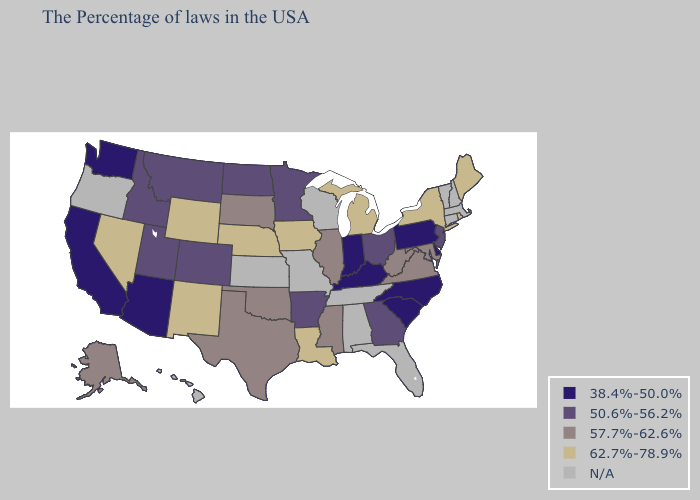Does the first symbol in the legend represent the smallest category?
Write a very short answer. Yes. Does New Jersey have the lowest value in the Northeast?
Answer briefly. No. What is the lowest value in the South?
Be succinct. 38.4%-50.0%. Among the states that border California , which have the lowest value?
Concise answer only. Arizona. Does Rhode Island have the highest value in the USA?
Short answer required. Yes. Which states have the lowest value in the South?
Keep it brief. Delaware, North Carolina, South Carolina, Kentucky. Name the states that have a value in the range 62.7%-78.9%?
Be succinct. Maine, Rhode Island, New York, Michigan, Louisiana, Iowa, Nebraska, Wyoming, New Mexico, Nevada. What is the value of Colorado?
Answer briefly. 50.6%-56.2%. Among the states that border Connecticut , which have the highest value?
Answer briefly. Rhode Island, New York. Does Maryland have the lowest value in the South?
Concise answer only. No. What is the lowest value in the South?
Concise answer only. 38.4%-50.0%. Which states have the lowest value in the USA?
Answer briefly. Delaware, Pennsylvania, North Carolina, South Carolina, Kentucky, Indiana, Arizona, California, Washington. Which states have the lowest value in the MidWest?
Concise answer only. Indiana. 